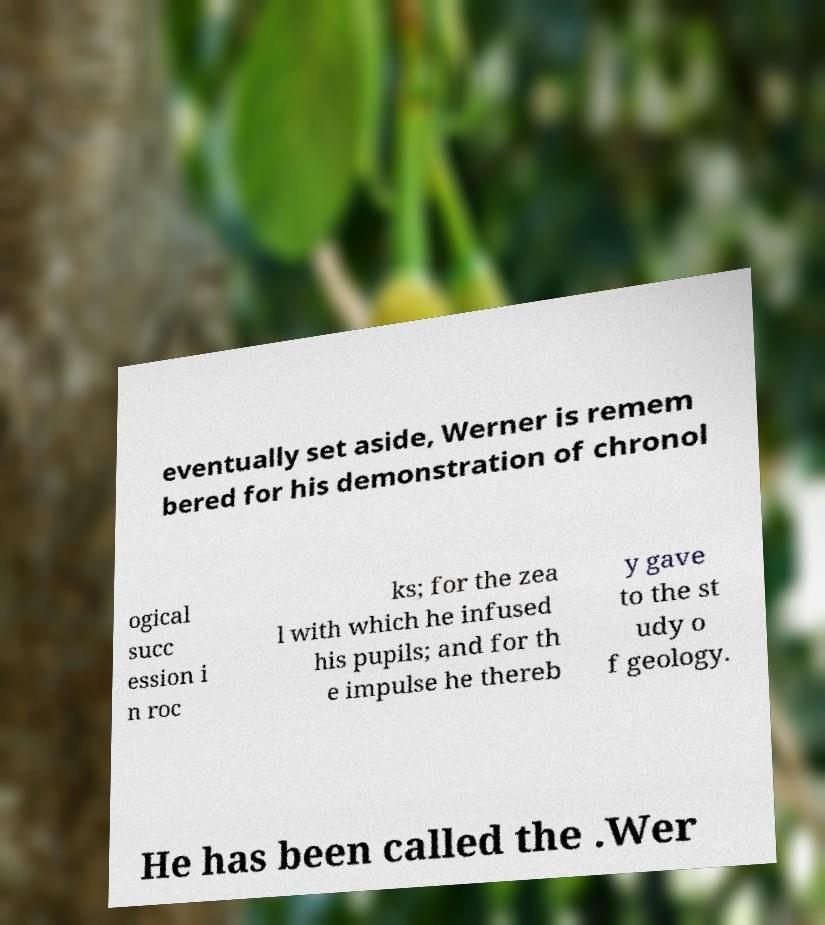There's text embedded in this image that I need extracted. Can you transcribe it verbatim? eventually set aside, Werner is remem bered for his demonstration of chronol ogical succ ession i n roc ks; for the zea l with which he infused his pupils; and for th e impulse he thereb y gave to the st udy o f geology. He has been called the .Wer 